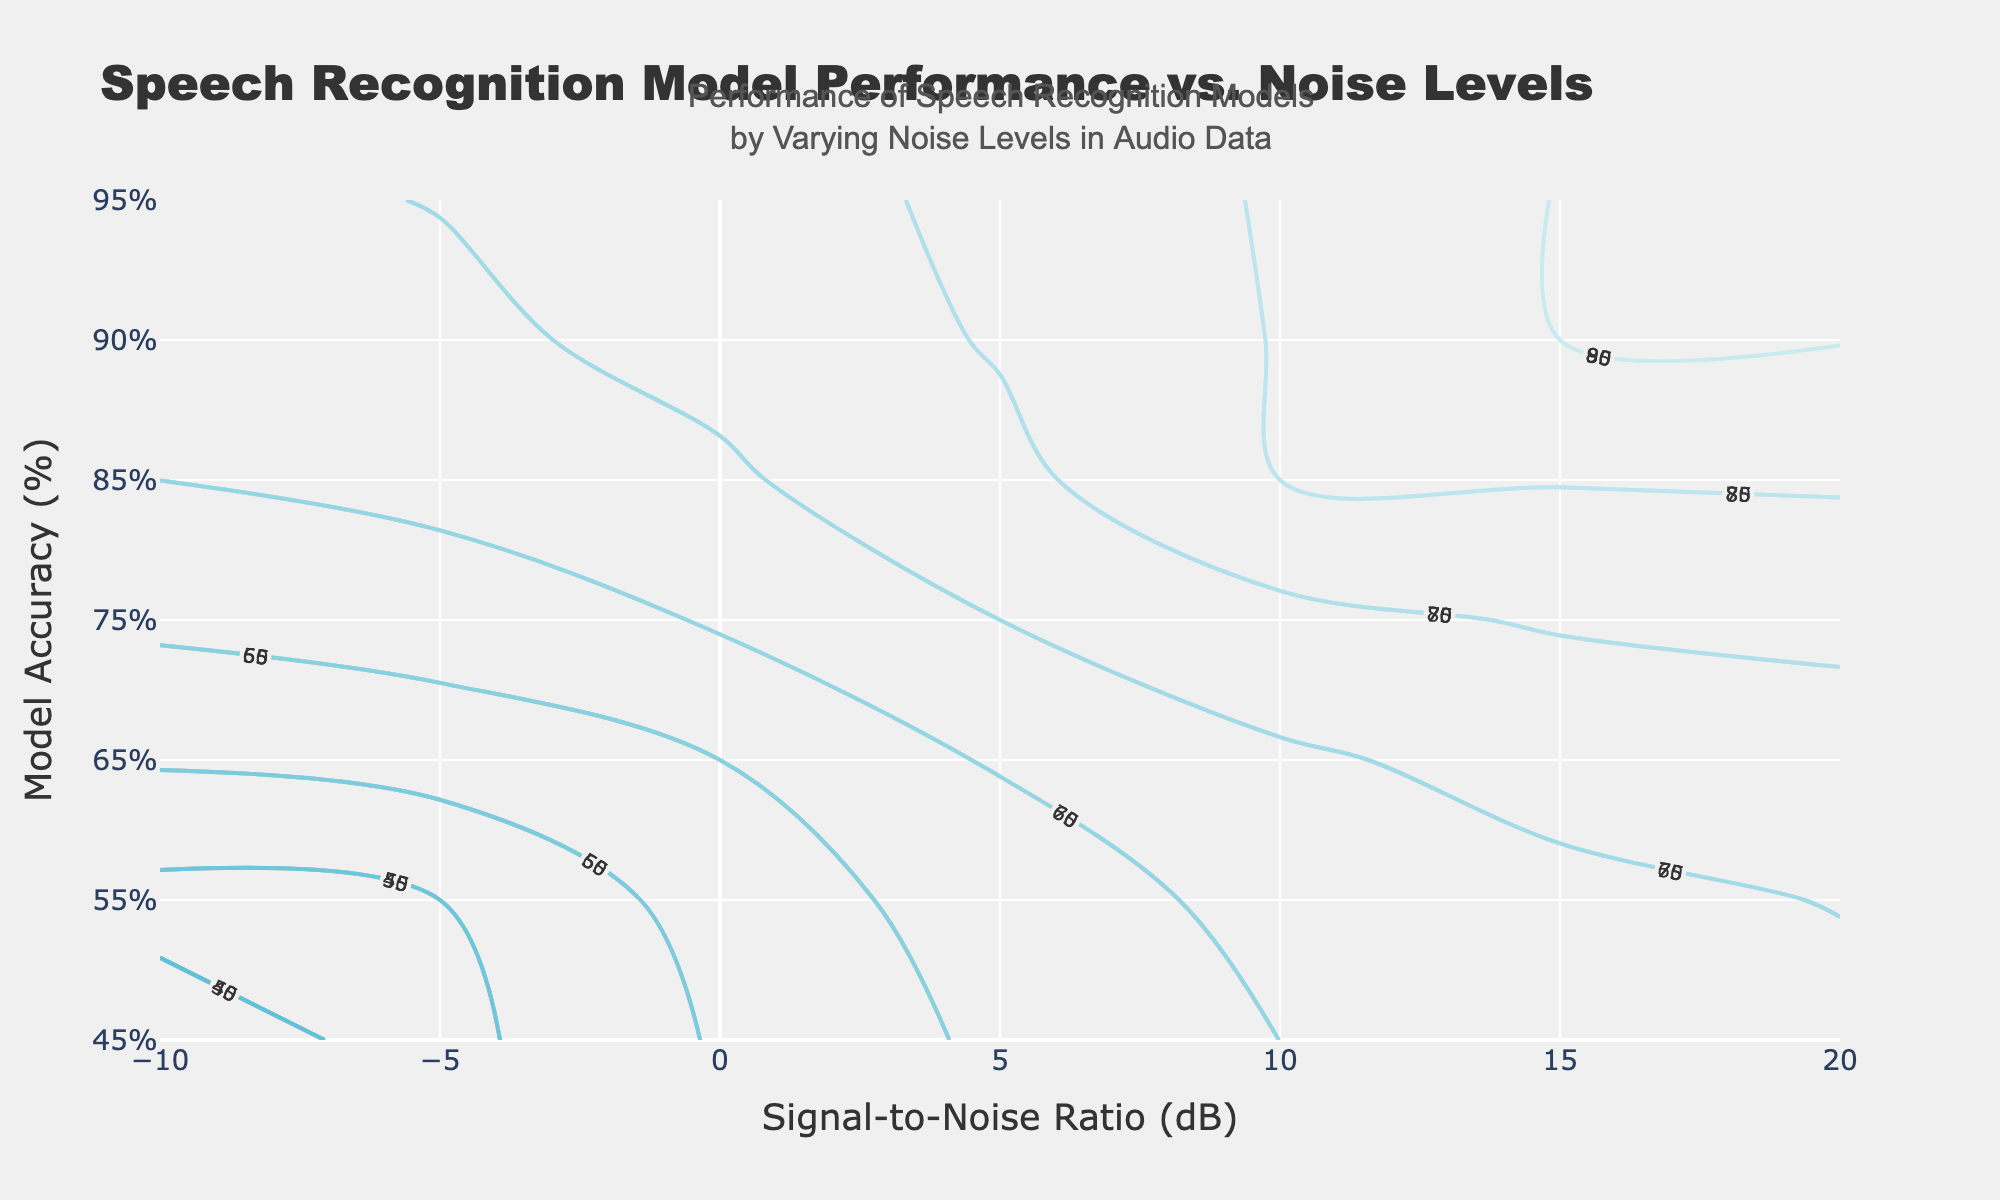What's the title of the plot? The title can be found at the top of the plot, as it is the main heading in larger text.
Answer: Speech Recognition Model Performance vs. Noise Levels What does the x-axis represent? The label at the bottom of the x-axis clearly indicates what it represents.
Answer: Signal-to-Noise Ratio (dB) What does the y-axis represent? The label at the side of the y-axis clearly indicates what it represents.
Answer: Model Accuracy (%) Which model has the highest accuracy at an SNR of 10 dB? By following the contour lines and labels at 10 dB on the x-axis, the highest accuracy value can be found.
Answer: Model A How does Model B's accuracy change from an SNR of 0 dB to 10 dB? By locating Model B’s contour lines at both 0 dB and 10 dB on the x-axis, the values can be compared to understand the change.
Answer: Increases from 60% to 80% What’s the average accuracy of Model C at SNR values of -5 dB, 5 dB, and 15 dB? Locate the accuracy values for Model C at -5 dB (45%), 5 dB (65%), and 15 dB (80%), sum these values, and then divide by the number of data points.
Answer: 63.33% Which model has the least performance improvement from an SNR of 5 dB to 10 dB? Calculate the performance improvement for all models between 5 dB and 10 dB, then compare them. Model A improves from 75% to 85% (10%), Model B from 70% to 80% (10%), Model C from 65% to 75% (10%). All models improve equally.
Answer: All models equally Is there a model whose performance exceeds 90% at any SNR value? If yes, which model and at what SNR value? Check the contour lines for accuracy values above 90%. Model A's accuracy exceeds 90% at SNR values above 15 dB.
Answer: Model A at SNR values above 15 dB Between which SNR levels does Model B show the most significant increase in accuracy? Calculate the differences in Model B's accuracy between consecutive SNR values and identify where the maximum increase occurs. The most significant increase is from 15 dB (85%) to 20 dB (90%).
Answer: From 15 dB to 20 dB 